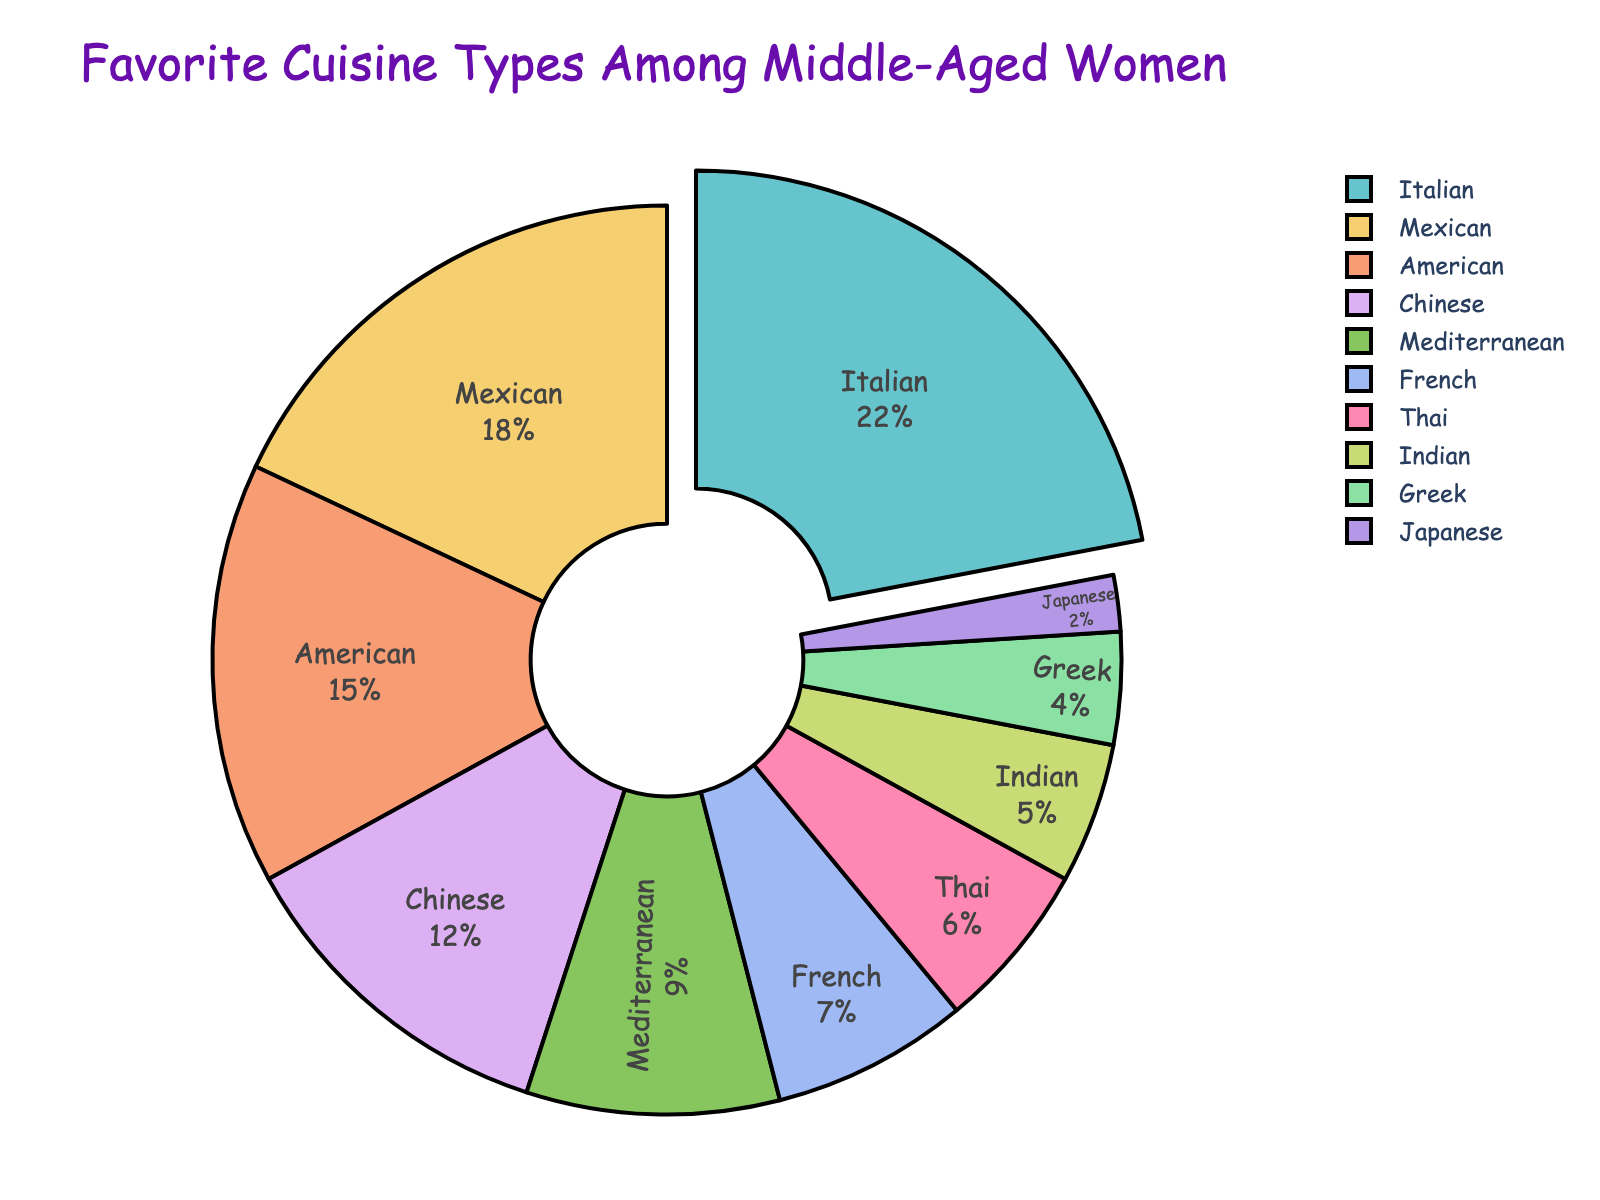Which cuisine type is the favorite among middle-aged women? The pie chart title indicates the favorite cuisine types among middle-aged women, and the largest slice represents the favorite cuisine.
Answer: Italian Which two cuisine types have the smallest percentages? The pie chart shows various slices with labeled percentages. The slices with the smallest percentages are easily identifiable as the two representing the smallest areas.
Answer: Japanese and Greek What's the total percentage for Mediterranean, French, Thai, and Indian cuisines combined? Add the percentages for Mediterranean (9), French (7), Thai (6), and Indian (5). 9 + 7 + 6 + 5 = 27
Answer: 27 How much more popular is Italian cuisine compared to Japanese cuisine? Subtract the percentage of Japanese cuisine (2) from the percentage of Italian cuisine (22). 22 - 2 = 20
Answer: 20 Which cuisine types each occupy exactly 10% more than the Thai cuisine? Thai cuisine has a percentage of 6. Add 10 to this to get 16. Look for cuisine types that equal 16%. There are none, so look for closest.
Answer: None Arrange the top three cuisines in descending order by their percentages. Look at the pie chart and determine the three largest slices. Then order them by their percentages from highest to lowest.
Answer: Italian, Mexican, American How do the combined percentages of Chinese and American cuisines compare with the percentage of Italian cuisine? Chinese cuisine holds 12% and American holds 15%. Combine these to find their total: 12 + 15 = 27. Compare this to Italian (22).
Answer: Combined is 27, Italian is 22 What percentage of the favorite cuisines are Asian cuisines? Add the percentages for the Asian cuisines: Chinese (12), Thai (6), Indian (5), Japanese (2). 12 + 6 + 5 + 2 = 25
Answer: 25 Which cuisine type is just one percentage point more popular than Mediterranean? Mediterranean is at 9%. The cuisine that is 1% higher would be 10%. There is no cuisine at exactly 10%, so look closest.
Answer: French (7) 